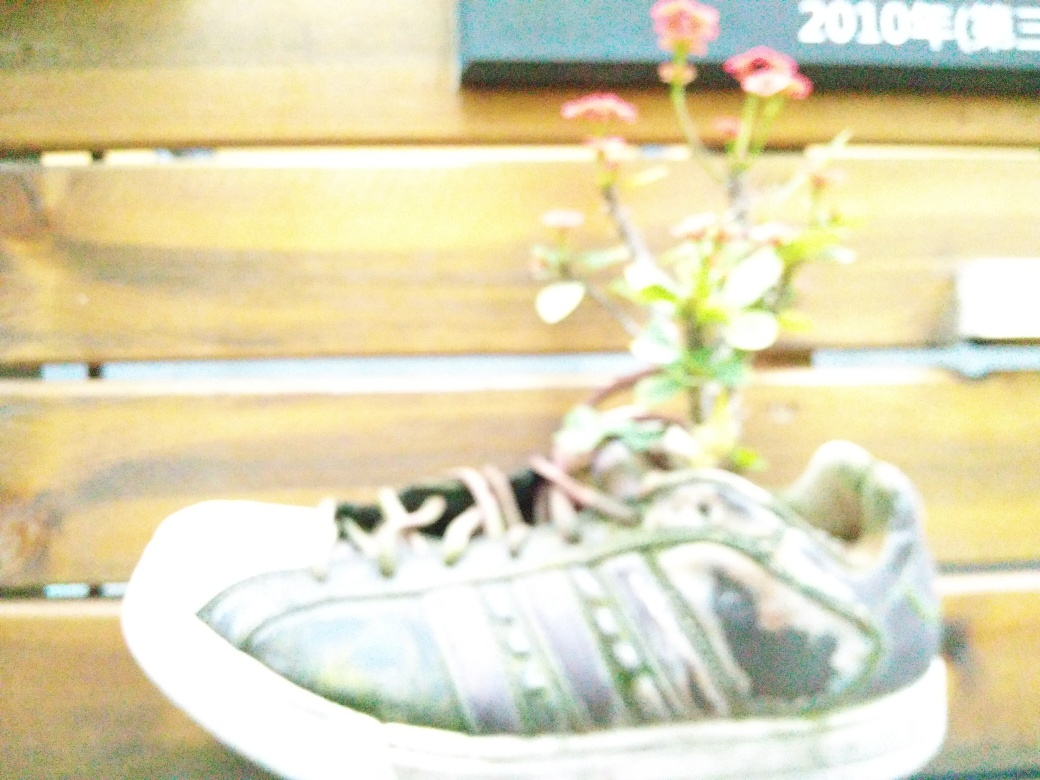Can this type of planting affect the longevity of the shoe, and are there ways to mitigate any potential damage? Yes, planting in a shoe can affect its longevity as the moisture from the soil and water can cause the material to deteriorate over time. To mitigate damage, one might use a liner inside the shoe to protect the material or apply a water sealant to the outer surface. Additionally, ensuring proper drainage and avoiding overwatering can help extend the life of a shoe-used-as-a-planter. 